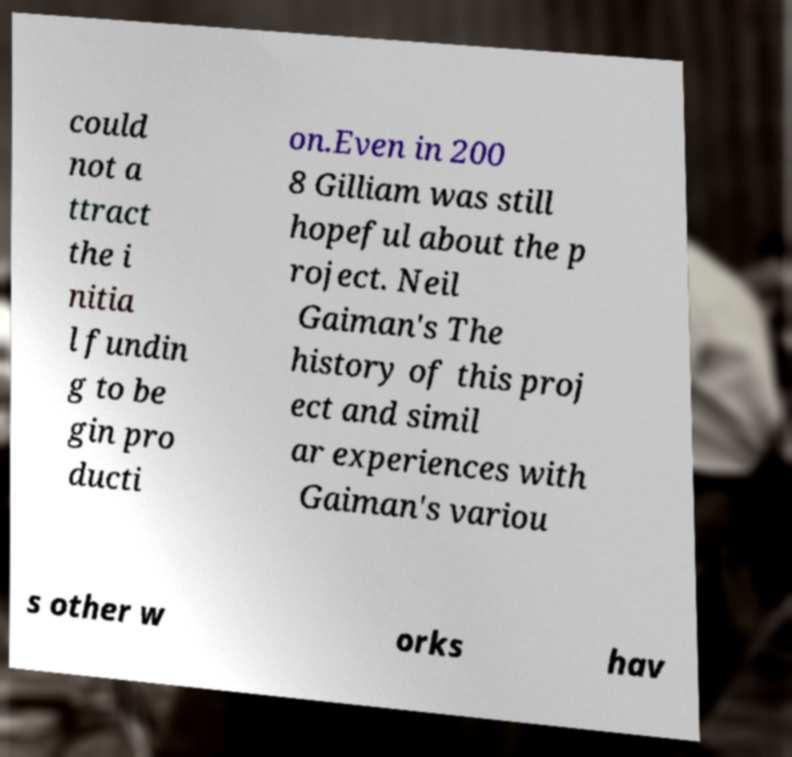Can you read and provide the text displayed in the image?This photo seems to have some interesting text. Can you extract and type it out for me? could not a ttract the i nitia l fundin g to be gin pro ducti on.Even in 200 8 Gilliam was still hopeful about the p roject. Neil Gaiman's The history of this proj ect and simil ar experiences with Gaiman's variou s other w orks hav 